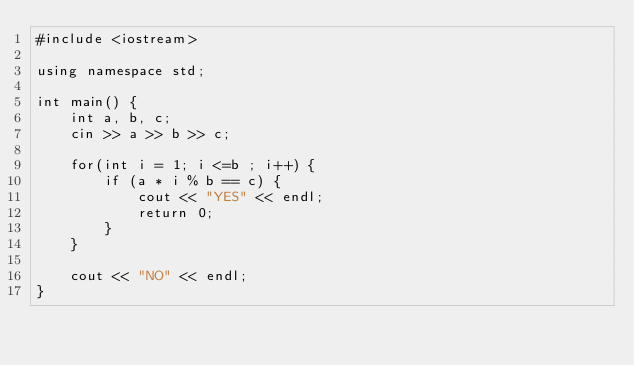<code> <loc_0><loc_0><loc_500><loc_500><_C++_>#include <iostream>

using namespace std;

int main() {
    int a, b, c;
    cin >> a >> b >> c;

    for(int i = 1; i <=b ; i++) {
        if (a * i % b == c) {
            cout << "YES" << endl;
            return 0;
        }
    }

    cout << "NO" << endl;
}
</code> 